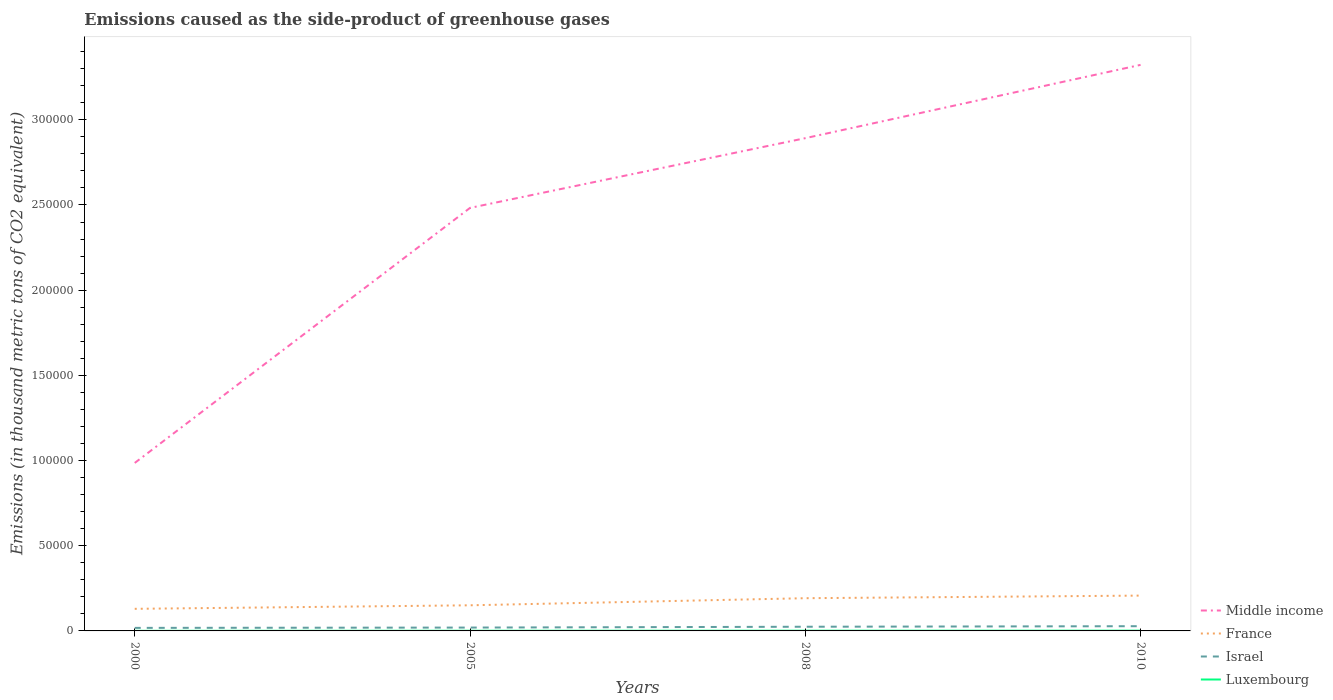How many different coloured lines are there?
Offer a terse response. 4. Is the number of lines equal to the number of legend labels?
Your answer should be very brief. Yes. Across all years, what is the maximum emissions caused as the side-product of greenhouse gases in France?
Your response must be concise. 1.30e+04. What is the total emissions caused as the side-product of greenhouse gases in Middle income in the graph?
Keep it short and to the point. -1.50e+05. What is the difference between the highest and the second highest emissions caused as the side-product of greenhouse gases in Luxembourg?
Keep it short and to the point. 93.9. What is the difference between the highest and the lowest emissions caused as the side-product of greenhouse gases in Luxembourg?
Your answer should be very brief. 2. How many years are there in the graph?
Provide a short and direct response. 4. What is the difference between two consecutive major ticks on the Y-axis?
Make the answer very short. 5.00e+04. Are the values on the major ticks of Y-axis written in scientific E-notation?
Keep it short and to the point. No. Does the graph contain any zero values?
Provide a succinct answer. No. Does the graph contain grids?
Offer a very short reply. No. How are the legend labels stacked?
Ensure brevity in your answer.  Vertical. What is the title of the graph?
Offer a very short reply. Emissions caused as the side-product of greenhouse gases. What is the label or title of the Y-axis?
Provide a succinct answer. Emissions (in thousand metric tons of CO2 equivalent). What is the Emissions (in thousand metric tons of CO2 equivalent) of Middle income in 2000?
Give a very brief answer. 9.86e+04. What is the Emissions (in thousand metric tons of CO2 equivalent) in France in 2000?
Give a very brief answer. 1.30e+04. What is the Emissions (in thousand metric tons of CO2 equivalent) of Israel in 2000?
Keep it short and to the point. 1787.6. What is the Emissions (in thousand metric tons of CO2 equivalent) of Luxembourg in 2000?
Offer a terse response. 52.1. What is the Emissions (in thousand metric tons of CO2 equivalent) in Middle income in 2005?
Keep it short and to the point. 2.48e+05. What is the Emissions (in thousand metric tons of CO2 equivalent) in France in 2005?
Provide a succinct answer. 1.50e+04. What is the Emissions (in thousand metric tons of CO2 equivalent) in Israel in 2005?
Your response must be concise. 1967.4. What is the Emissions (in thousand metric tons of CO2 equivalent) in Luxembourg in 2005?
Provide a succinct answer. 100.6. What is the Emissions (in thousand metric tons of CO2 equivalent) in Middle income in 2008?
Your answer should be very brief. 2.89e+05. What is the Emissions (in thousand metric tons of CO2 equivalent) of France in 2008?
Make the answer very short. 1.92e+04. What is the Emissions (in thousand metric tons of CO2 equivalent) in Israel in 2008?
Provide a short and direct response. 2452.1. What is the Emissions (in thousand metric tons of CO2 equivalent) in Luxembourg in 2008?
Your answer should be compact. 132.4. What is the Emissions (in thousand metric tons of CO2 equivalent) of Middle income in 2010?
Make the answer very short. 3.32e+05. What is the Emissions (in thousand metric tons of CO2 equivalent) in France in 2010?
Provide a short and direct response. 2.07e+04. What is the Emissions (in thousand metric tons of CO2 equivalent) in Israel in 2010?
Your answer should be very brief. 2777. What is the Emissions (in thousand metric tons of CO2 equivalent) of Luxembourg in 2010?
Keep it short and to the point. 146. Across all years, what is the maximum Emissions (in thousand metric tons of CO2 equivalent) of Middle income?
Give a very brief answer. 3.32e+05. Across all years, what is the maximum Emissions (in thousand metric tons of CO2 equivalent) in France?
Make the answer very short. 2.07e+04. Across all years, what is the maximum Emissions (in thousand metric tons of CO2 equivalent) of Israel?
Offer a very short reply. 2777. Across all years, what is the maximum Emissions (in thousand metric tons of CO2 equivalent) in Luxembourg?
Provide a succinct answer. 146. Across all years, what is the minimum Emissions (in thousand metric tons of CO2 equivalent) in Middle income?
Your response must be concise. 9.86e+04. Across all years, what is the minimum Emissions (in thousand metric tons of CO2 equivalent) in France?
Give a very brief answer. 1.30e+04. Across all years, what is the minimum Emissions (in thousand metric tons of CO2 equivalent) in Israel?
Your answer should be very brief. 1787.6. Across all years, what is the minimum Emissions (in thousand metric tons of CO2 equivalent) in Luxembourg?
Provide a succinct answer. 52.1. What is the total Emissions (in thousand metric tons of CO2 equivalent) in Middle income in the graph?
Offer a terse response. 9.68e+05. What is the total Emissions (in thousand metric tons of CO2 equivalent) of France in the graph?
Provide a short and direct response. 6.79e+04. What is the total Emissions (in thousand metric tons of CO2 equivalent) of Israel in the graph?
Offer a terse response. 8984.1. What is the total Emissions (in thousand metric tons of CO2 equivalent) in Luxembourg in the graph?
Keep it short and to the point. 431.1. What is the difference between the Emissions (in thousand metric tons of CO2 equivalent) in Middle income in 2000 and that in 2005?
Offer a terse response. -1.50e+05. What is the difference between the Emissions (in thousand metric tons of CO2 equivalent) in France in 2000 and that in 2005?
Give a very brief answer. -2068. What is the difference between the Emissions (in thousand metric tons of CO2 equivalent) in Israel in 2000 and that in 2005?
Offer a very short reply. -179.8. What is the difference between the Emissions (in thousand metric tons of CO2 equivalent) in Luxembourg in 2000 and that in 2005?
Offer a terse response. -48.5. What is the difference between the Emissions (in thousand metric tons of CO2 equivalent) of Middle income in 2000 and that in 2008?
Offer a very short reply. -1.91e+05. What is the difference between the Emissions (in thousand metric tons of CO2 equivalent) of France in 2000 and that in 2008?
Offer a terse response. -6233.8. What is the difference between the Emissions (in thousand metric tons of CO2 equivalent) in Israel in 2000 and that in 2008?
Ensure brevity in your answer.  -664.5. What is the difference between the Emissions (in thousand metric tons of CO2 equivalent) in Luxembourg in 2000 and that in 2008?
Provide a succinct answer. -80.3. What is the difference between the Emissions (in thousand metric tons of CO2 equivalent) of Middle income in 2000 and that in 2010?
Give a very brief answer. -2.34e+05. What is the difference between the Emissions (in thousand metric tons of CO2 equivalent) in France in 2000 and that in 2010?
Give a very brief answer. -7761.8. What is the difference between the Emissions (in thousand metric tons of CO2 equivalent) of Israel in 2000 and that in 2010?
Give a very brief answer. -989.4. What is the difference between the Emissions (in thousand metric tons of CO2 equivalent) in Luxembourg in 2000 and that in 2010?
Provide a short and direct response. -93.9. What is the difference between the Emissions (in thousand metric tons of CO2 equivalent) of Middle income in 2005 and that in 2008?
Provide a succinct answer. -4.09e+04. What is the difference between the Emissions (in thousand metric tons of CO2 equivalent) of France in 2005 and that in 2008?
Provide a short and direct response. -4165.8. What is the difference between the Emissions (in thousand metric tons of CO2 equivalent) in Israel in 2005 and that in 2008?
Give a very brief answer. -484.7. What is the difference between the Emissions (in thousand metric tons of CO2 equivalent) of Luxembourg in 2005 and that in 2008?
Your answer should be very brief. -31.8. What is the difference between the Emissions (in thousand metric tons of CO2 equivalent) of Middle income in 2005 and that in 2010?
Your answer should be compact. -8.40e+04. What is the difference between the Emissions (in thousand metric tons of CO2 equivalent) in France in 2005 and that in 2010?
Your response must be concise. -5693.8. What is the difference between the Emissions (in thousand metric tons of CO2 equivalent) in Israel in 2005 and that in 2010?
Give a very brief answer. -809.6. What is the difference between the Emissions (in thousand metric tons of CO2 equivalent) of Luxembourg in 2005 and that in 2010?
Your answer should be compact. -45.4. What is the difference between the Emissions (in thousand metric tons of CO2 equivalent) in Middle income in 2008 and that in 2010?
Your response must be concise. -4.30e+04. What is the difference between the Emissions (in thousand metric tons of CO2 equivalent) of France in 2008 and that in 2010?
Offer a very short reply. -1528. What is the difference between the Emissions (in thousand metric tons of CO2 equivalent) in Israel in 2008 and that in 2010?
Your response must be concise. -324.9. What is the difference between the Emissions (in thousand metric tons of CO2 equivalent) of Luxembourg in 2008 and that in 2010?
Provide a short and direct response. -13.6. What is the difference between the Emissions (in thousand metric tons of CO2 equivalent) of Middle income in 2000 and the Emissions (in thousand metric tons of CO2 equivalent) of France in 2005?
Your response must be concise. 8.36e+04. What is the difference between the Emissions (in thousand metric tons of CO2 equivalent) of Middle income in 2000 and the Emissions (in thousand metric tons of CO2 equivalent) of Israel in 2005?
Offer a terse response. 9.66e+04. What is the difference between the Emissions (in thousand metric tons of CO2 equivalent) in Middle income in 2000 and the Emissions (in thousand metric tons of CO2 equivalent) in Luxembourg in 2005?
Your answer should be compact. 9.85e+04. What is the difference between the Emissions (in thousand metric tons of CO2 equivalent) of France in 2000 and the Emissions (in thousand metric tons of CO2 equivalent) of Israel in 2005?
Ensure brevity in your answer.  1.10e+04. What is the difference between the Emissions (in thousand metric tons of CO2 equivalent) of France in 2000 and the Emissions (in thousand metric tons of CO2 equivalent) of Luxembourg in 2005?
Your answer should be compact. 1.29e+04. What is the difference between the Emissions (in thousand metric tons of CO2 equivalent) of Israel in 2000 and the Emissions (in thousand metric tons of CO2 equivalent) of Luxembourg in 2005?
Provide a succinct answer. 1687. What is the difference between the Emissions (in thousand metric tons of CO2 equivalent) of Middle income in 2000 and the Emissions (in thousand metric tons of CO2 equivalent) of France in 2008?
Your response must be concise. 7.94e+04. What is the difference between the Emissions (in thousand metric tons of CO2 equivalent) in Middle income in 2000 and the Emissions (in thousand metric tons of CO2 equivalent) in Israel in 2008?
Your response must be concise. 9.61e+04. What is the difference between the Emissions (in thousand metric tons of CO2 equivalent) of Middle income in 2000 and the Emissions (in thousand metric tons of CO2 equivalent) of Luxembourg in 2008?
Make the answer very short. 9.85e+04. What is the difference between the Emissions (in thousand metric tons of CO2 equivalent) in France in 2000 and the Emissions (in thousand metric tons of CO2 equivalent) in Israel in 2008?
Your answer should be very brief. 1.05e+04. What is the difference between the Emissions (in thousand metric tons of CO2 equivalent) of France in 2000 and the Emissions (in thousand metric tons of CO2 equivalent) of Luxembourg in 2008?
Provide a short and direct response. 1.28e+04. What is the difference between the Emissions (in thousand metric tons of CO2 equivalent) in Israel in 2000 and the Emissions (in thousand metric tons of CO2 equivalent) in Luxembourg in 2008?
Your answer should be very brief. 1655.2. What is the difference between the Emissions (in thousand metric tons of CO2 equivalent) in Middle income in 2000 and the Emissions (in thousand metric tons of CO2 equivalent) in France in 2010?
Make the answer very short. 7.79e+04. What is the difference between the Emissions (in thousand metric tons of CO2 equivalent) of Middle income in 2000 and the Emissions (in thousand metric tons of CO2 equivalent) of Israel in 2010?
Offer a terse response. 9.58e+04. What is the difference between the Emissions (in thousand metric tons of CO2 equivalent) of Middle income in 2000 and the Emissions (in thousand metric tons of CO2 equivalent) of Luxembourg in 2010?
Keep it short and to the point. 9.84e+04. What is the difference between the Emissions (in thousand metric tons of CO2 equivalent) in France in 2000 and the Emissions (in thousand metric tons of CO2 equivalent) in Israel in 2010?
Provide a succinct answer. 1.02e+04. What is the difference between the Emissions (in thousand metric tons of CO2 equivalent) of France in 2000 and the Emissions (in thousand metric tons of CO2 equivalent) of Luxembourg in 2010?
Offer a very short reply. 1.28e+04. What is the difference between the Emissions (in thousand metric tons of CO2 equivalent) of Israel in 2000 and the Emissions (in thousand metric tons of CO2 equivalent) of Luxembourg in 2010?
Offer a terse response. 1641.6. What is the difference between the Emissions (in thousand metric tons of CO2 equivalent) in Middle income in 2005 and the Emissions (in thousand metric tons of CO2 equivalent) in France in 2008?
Provide a short and direct response. 2.29e+05. What is the difference between the Emissions (in thousand metric tons of CO2 equivalent) of Middle income in 2005 and the Emissions (in thousand metric tons of CO2 equivalent) of Israel in 2008?
Ensure brevity in your answer.  2.46e+05. What is the difference between the Emissions (in thousand metric tons of CO2 equivalent) of Middle income in 2005 and the Emissions (in thousand metric tons of CO2 equivalent) of Luxembourg in 2008?
Keep it short and to the point. 2.48e+05. What is the difference between the Emissions (in thousand metric tons of CO2 equivalent) in France in 2005 and the Emissions (in thousand metric tons of CO2 equivalent) in Israel in 2008?
Keep it short and to the point. 1.26e+04. What is the difference between the Emissions (in thousand metric tons of CO2 equivalent) of France in 2005 and the Emissions (in thousand metric tons of CO2 equivalent) of Luxembourg in 2008?
Provide a succinct answer. 1.49e+04. What is the difference between the Emissions (in thousand metric tons of CO2 equivalent) in Israel in 2005 and the Emissions (in thousand metric tons of CO2 equivalent) in Luxembourg in 2008?
Offer a very short reply. 1835. What is the difference between the Emissions (in thousand metric tons of CO2 equivalent) of Middle income in 2005 and the Emissions (in thousand metric tons of CO2 equivalent) of France in 2010?
Provide a succinct answer. 2.28e+05. What is the difference between the Emissions (in thousand metric tons of CO2 equivalent) of Middle income in 2005 and the Emissions (in thousand metric tons of CO2 equivalent) of Israel in 2010?
Your response must be concise. 2.46e+05. What is the difference between the Emissions (in thousand metric tons of CO2 equivalent) of Middle income in 2005 and the Emissions (in thousand metric tons of CO2 equivalent) of Luxembourg in 2010?
Your answer should be compact. 2.48e+05. What is the difference between the Emissions (in thousand metric tons of CO2 equivalent) of France in 2005 and the Emissions (in thousand metric tons of CO2 equivalent) of Israel in 2010?
Ensure brevity in your answer.  1.23e+04. What is the difference between the Emissions (in thousand metric tons of CO2 equivalent) in France in 2005 and the Emissions (in thousand metric tons of CO2 equivalent) in Luxembourg in 2010?
Your answer should be very brief. 1.49e+04. What is the difference between the Emissions (in thousand metric tons of CO2 equivalent) of Israel in 2005 and the Emissions (in thousand metric tons of CO2 equivalent) of Luxembourg in 2010?
Give a very brief answer. 1821.4. What is the difference between the Emissions (in thousand metric tons of CO2 equivalent) of Middle income in 2008 and the Emissions (in thousand metric tons of CO2 equivalent) of France in 2010?
Provide a succinct answer. 2.68e+05. What is the difference between the Emissions (in thousand metric tons of CO2 equivalent) of Middle income in 2008 and the Emissions (in thousand metric tons of CO2 equivalent) of Israel in 2010?
Your answer should be very brief. 2.86e+05. What is the difference between the Emissions (in thousand metric tons of CO2 equivalent) in Middle income in 2008 and the Emissions (in thousand metric tons of CO2 equivalent) in Luxembourg in 2010?
Your response must be concise. 2.89e+05. What is the difference between the Emissions (in thousand metric tons of CO2 equivalent) of France in 2008 and the Emissions (in thousand metric tons of CO2 equivalent) of Israel in 2010?
Your response must be concise. 1.64e+04. What is the difference between the Emissions (in thousand metric tons of CO2 equivalent) of France in 2008 and the Emissions (in thousand metric tons of CO2 equivalent) of Luxembourg in 2010?
Your answer should be compact. 1.91e+04. What is the difference between the Emissions (in thousand metric tons of CO2 equivalent) in Israel in 2008 and the Emissions (in thousand metric tons of CO2 equivalent) in Luxembourg in 2010?
Provide a succinct answer. 2306.1. What is the average Emissions (in thousand metric tons of CO2 equivalent) of Middle income per year?
Your response must be concise. 2.42e+05. What is the average Emissions (in thousand metric tons of CO2 equivalent) in France per year?
Make the answer very short. 1.70e+04. What is the average Emissions (in thousand metric tons of CO2 equivalent) of Israel per year?
Ensure brevity in your answer.  2246.03. What is the average Emissions (in thousand metric tons of CO2 equivalent) of Luxembourg per year?
Provide a succinct answer. 107.78. In the year 2000, what is the difference between the Emissions (in thousand metric tons of CO2 equivalent) of Middle income and Emissions (in thousand metric tons of CO2 equivalent) of France?
Ensure brevity in your answer.  8.56e+04. In the year 2000, what is the difference between the Emissions (in thousand metric tons of CO2 equivalent) of Middle income and Emissions (in thousand metric tons of CO2 equivalent) of Israel?
Offer a very short reply. 9.68e+04. In the year 2000, what is the difference between the Emissions (in thousand metric tons of CO2 equivalent) of Middle income and Emissions (in thousand metric tons of CO2 equivalent) of Luxembourg?
Your response must be concise. 9.85e+04. In the year 2000, what is the difference between the Emissions (in thousand metric tons of CO2 equivalent) of France and Emissions (in thousand metric tons of CO2 equivalent) of Israel?
Give a very brief answer. 1.12e+04. In the year 2000, what is the difference between the Emissions (in thousand metric tons of CO2 equivalent) in France and Emissions (in thousand metric tons of CO2 equivalent) in Luxembourg?
Make the answer very short. 1.29e+04. In the year 2000, what is the difference between the Emissions (in thousand metric tons of CO2 equivalent) in Israel and Emissions (in thousand metric tons of CO2 equivalent) in Luxembourg?
Offer a very short reply. 1735.5. In the year 2005, what is the difference between the Emissions (in thousand metric tons of CO2 equivalent) of Middle income and Emissions (in thousand metric tons of CO2 equivalent) of France?
Your answer should be very brief. 2.33e+05. In the year 2005, what is the difference between the Emissions (in thousand metric tons of CO2 equivalent) of Middle income and Emissions (in thousand metric tons of CO2 equivalent) of Israel?
Your response must be concise. 2.46e+05. In the year 2005, what is the difference between the Emissions (in thousand metric tons of CO2 equivalent) of Middle income and Emissions (in thousand metric tons of CO2 equivalent) of Luxembourg?
Offer a terse response. 2.48e+05. In the year 2005, what is the difference between the Emissions (in thousand metric tons of CO2 equivalent) in France and Emissions (in thousand metric tons of CO2 equivalent) in Israel?
Your response must be concise. 1.31e+04. In the year 2005, what is the difference between the Emissions (in thousand metric tons of CO2 equivalent) of France and Emissions (in thousand metric tons of CO2 equivalent) of Luxembourg?
Give a very brief answer. 1.49e+04. In the year 2005, what is the difference between the Emissions (in thousand metric tons of CO2 equivalent) in Israel and Emissions (in thousand metric tons of CO2 equivalent) in Luxembourg?
Provide a short and direct response. 1866.8. In the year 2008, what is the difference between the Emissions (in thousand metric tons of CO2 equivalent) of Middle income and Emissions (in thousand metric tons of CO2 equivalent) of France?
Provide a succinct answer. 2.70e+05. In the year 2008, what is the difference between the Emissions (in thousand metric tons of CO2 equivalent) in Middle income and Emissions (in thousand metric tons of CO2 equivalent) in Israel?
Offer a very short reply. 2.87e+05. In the year 2008, what is the difference between the Emissions (in thousand metric tons of CO2 equivalent) of Middle income and Emissions (in thousand metric tons of CO2 equivalent) of Luxembourg?
Offer a very short reply. 2.89e+05. In the year 2008, what is the difference between the Emissions (in thousand metric tons of CO2 equivalent) in France and Emissions (in thousand metric tons of CO2 equivalent) in Israel?
Your answer should be very brief. 1.68e+04. In the year 2008, what is the difference between the Emissions (in thousand metric tons of CO2 equivalent) in France and Emissions (in thousand metric tons of CO2 equivalent) in Luxembourg?
Ensure brevity in your answer.  1.91e+04. In the year 2008, what is the difference between the Emissions (in thousand metric tons of CO2 equivalent) in Israel and Emissions (in thousand metric tons of CO2 equivalent) in Luxembourg?
Make the answer very short. 2319.7. In the year 2010, what is the difference between the Emissions (in thousand metric tons of CO2 equivalent) of Middle income and Emissions (in thousand metric tons of CO2 equivalent) of France?
Your answer should be compact. 3.12e+05. In the year 2010, what is the difference between the Emissions (in thousand metric tons of CO2 equivalent) in Middle income and Emissions (in thousand metric tons of CO2 equivalent) in Israel?
Give a very brief answer. 3.29e+05. In the year 2010, what is the difference between the Emissions (in thousand metric tons of CO2 equivalent) in Middle income and Emissions (in thousand metric tons of CO2 equivalent) in Luxembourg?
Your answer should be very brief. 3.32e+05. In the year 2010, what is the difference between the Emissions (in thousand metric tons of CO2 equivalent) in France and Emissions (in thousand metric tons of CO2 equivalent) in Israel?
Provide a succinct answer. 1.80e+04. In the year 2010, what is the difference between the Emissions (in thousand metric tons of CO2 equivalent) of France and Emissions (in thousand metric tons of CO2 equivalent) of Luxembourg?
Provide a short and direct response. 2.06e+04. In the year 2010, what is the difference between the Emissions (in thousand metric tons of CO2 equivalent) of Israel and Emissions (in thousand metric tons of CO2 equivalent) of Luxembourg?
Provide a short and direct response. 2631. What is the ratio of the Emissions (in thousand metric tons of CO2 equivalent) in Middle income in 2000 to that in 2005?
Give a very brief answer. 0.4. What is the ratio of the Emissions (in thousand metric tons of CO2 equivalent) of France in 2000 to that in 2005?
Make the answer very short. 0.86. What is the ratio of the Emissions (in thousand metric tons of CO2 equivalent) in Israel in 2000 to that in 2005?
Keep it short and to the point. 0.91. What is the ratio of the Emissions (in thousand metric tons of CO2 equivalent) in Luxembourg in 2000 to that in 2005?
Offer a very short reply. 0.52. What is the ratio of the Emissions (in thousand metric tons of CO2 equivalent) in Middle income in 2000 to that in 2008?
Make the answer very short. 0.34. What is the ratio of the Emissions (in thousand metric tons of CO2 equivalent) in France in 2000 to that in 2008?
Offer a very short reply. 0.68. What is the ratio of the Emissions (in thousand metric tons of CO2 equivalent) in Israel in 2000 to that in 2008?
Provide a short and direct response. 0.73. What is the ratio of the Emissions (in thousand metric tons of CO2 equivalent) of Luxembourg in 2000 to that in 2008?
Offer a terse response. 0.39. What is the ratio of the Emissions (in thousand metric tons of CO2 equivalent) in Middle income in 2000 to that in 2010?
Your answer should be very brief. 0.3. What is the ratio of the Emissions (in thousand metric tons of CO2 equivalent) in France in 2000 to that in 2010?
Provide a succinct answer. 0.63. What is the ratio of the Emissions (in thousand metric tons of CO2 equivalent) of Israel in 2000 to that in 2010?
Give a very brief answer. 0.64. What is the ratio of the Emissions (in thousand metric tons of CO2 equivalent) of Luxembourg in 2000 to that in 2010?
Provide a short and direct response. 0.36. What is the ratio of the Emissions (in thousand metric tons of CO2 equivalent) in Middle income in 2005 to that in 2008?
Make the answer very short. 0.86. What is the ratio of the Emissions (in thousand metric tons of CO2 equivalent) in France in 2005 to that in 2008?
Provide a short and direct response. 0.78. What is the ratio of the Emissions (in thousand metric tons of CO2 equivalent) in Israel in 2005 to that in 2008?
Your answer should be very brief. 0.8. What is the ratio of the Emissions (in thousand metric tons of CO2 equivalent) in Luxembourg in 2005 to that in 2008?
Your response must be concise. 0.76. What is the ratio of the Emissions (in thousand metric tons of CO2 equivalent) in Middle income in 2005 to that in 2010?
Provide a succinct answer. 0.75. What is the ratio of the Emissions (in thousand metric tons of CO2 equivalent) of France in 2005 to that in 2010?
Make the answer very short. 0.73. What is the ratio of the Emissions (in thousand metric tons of CO2 equivalent) of Israel in 2005 to that in 2010?
Offer a very short reply. 0.71. What is the ratio of the Emissions (in thousand metric tons of CO2 equivalent) in Luxembourg in 2005 to that in 2010?
Keep it short and to the point. 0.69. What is the ratio of the Emissions (in thousand metric tons of CO2 equivalent) in Middle income in 2008 to that in 2010?
Your answer should be very brief. 0.87. What is the ratio of the Emissions (in thousand metric tons of CO2 equivalent) of France in 2008 to that in 2010?
Give a very brief answer. 0.93. What is the ratio of the Emissions (in thousand metric tons of CO2 equivalent) of Israel in 2008 to that in 2010?
Offer a very short reply. 0.88. What is the ratio of the Emissions (in thousand metric tons of CO2 equivalent) in Luxembourg in 2008 to that in 2010?
Provide a succinct answer. 0.91. What is the difference between the highest and the second highest Emissions (in thousand metric tons of CO2 equivalent) in Middle income?
Offer a terse response. 4.30e+04. What is the difference between the highest and the second highest Emissions (in thousand metric tons of CO2 equivalent) in France?
Offer a very short reply. 1528. What is the difference between the highest and the second highest Emissions (in thousand metric tons of CO2 equivalent) of Israel?
Offer a very short reply. 324.9. What is the difference between the highest and the second highest Emissions (in thousand metric tons of CO2 equivalent) of Luxembourg?
Offer a very short reply. 13.6. What is the difference between the highest and the lowest Emissions (in thousand metric tons of CO2 equivalent) of Middle income?
Keep it short and to the point. 2.34e+05. What is the difference between the highest and the lowest Emissions (in thousand metric tons of CO2 equivalent) in France?
Ensure brevity in your answer.  7761.8. What is the difference between the highest and the lowest Emissions (in thousand metric tons of CO2 equivalent) of Israel?
Keep it short and to the point. 989.4. What is the difference between the highest and the lowest Emissions (in thousand metric tons of CO2 equivalent) of Luxembourg?
Keep it short and to the point. 93.9. 